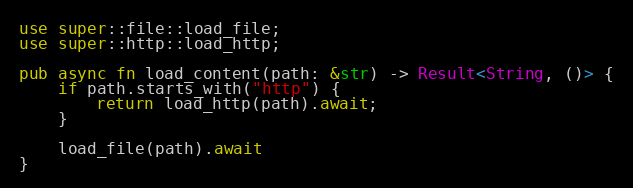<code> <loc_0><loc_0><loc_500><loc_500><_Rust_>use super::file::load_file;
use super::http::load_http;

pub async fn load_content(path: &str) -> Result<String, ()> {
    if path.starts_with("http") {
        return load_http(path).await;
    }

    load_file(path).await
}
</code> 